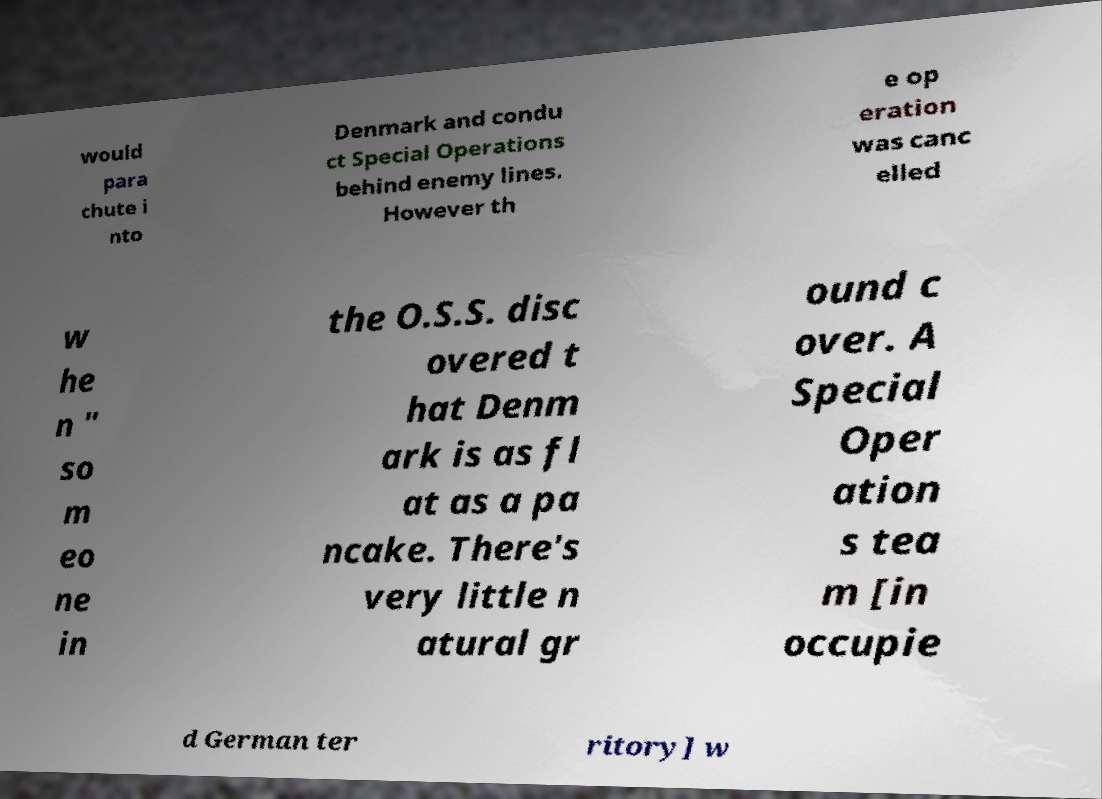There's text embedded in this image that I need extracted. Can you transcribe it verbatim? would para chute i nto Denmark and condu ct Special Operations behind enemy lines. However th e op eration was canc elled w he n " so m eo ne in the O.S.S. disc overed t hat Denm ark is as fl at as a pa ncake. There's very little n atural gr ound c over. A Special Oper ation s tea m [in occupie d German ter ritory] w 